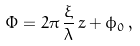Convert formula to latex. <formula><loc_0><loc_0><loc_500><loc_500>\Phi = 2 \pi \, \frac { \xi } { \lambda } \, z + \phi _ { 0 } \, ,</formula> 